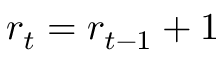Convert formula to latex. <formula><loc_0><loc_0><loc_500><loc_500>r _ { t } = r _ { t - 1 } + 1</formula> 